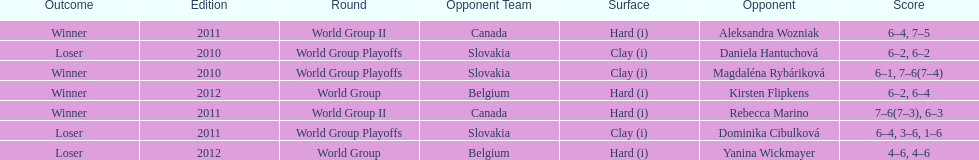Number of games in the match against dominika cibulkova? 3. 